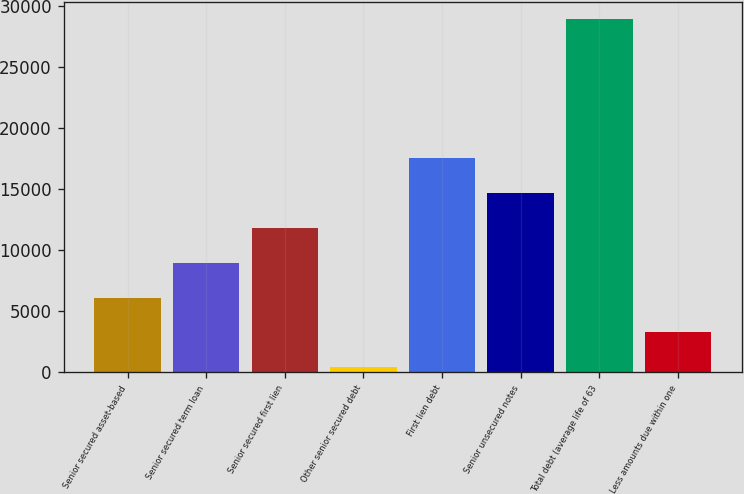Convert chart to OTSL. <chart><loc_0><loc_0><loc_500><loc_500><bar_chart><fcel>Senior secured asset-based<fcel>Senior secured term loan<fcel>Senior secured first lien<fcel>Other senior secured debt<fcel>First lien debt<fcel>Senior unsecured notes<fcel>Total debt (average life of 63<fcel>Less amounts due within one<nl><fcel>6124.4<fcel>8975.1<fcel>11825.8<fcel>423<fcel>17539<fcel>14676.5<fcel>28930<fcel>3273.7<nl></chart> 